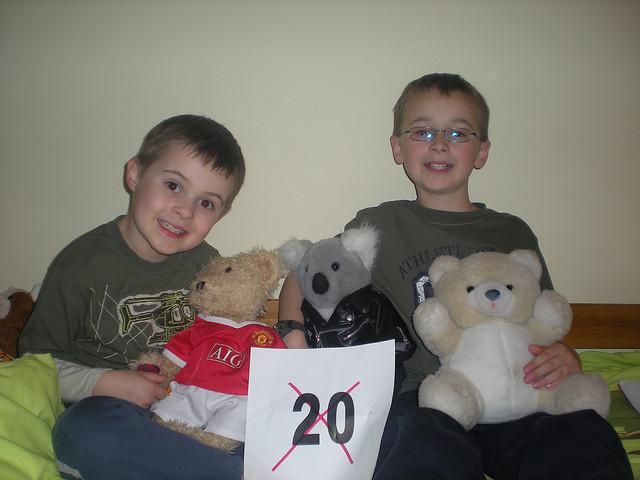How many bears are being held?
Give a very brief answer. 3. How many people are in the picture?
Give a very brief answer. 2. How many teddy bears are in the photo?
Give a very brief answer. 3. 